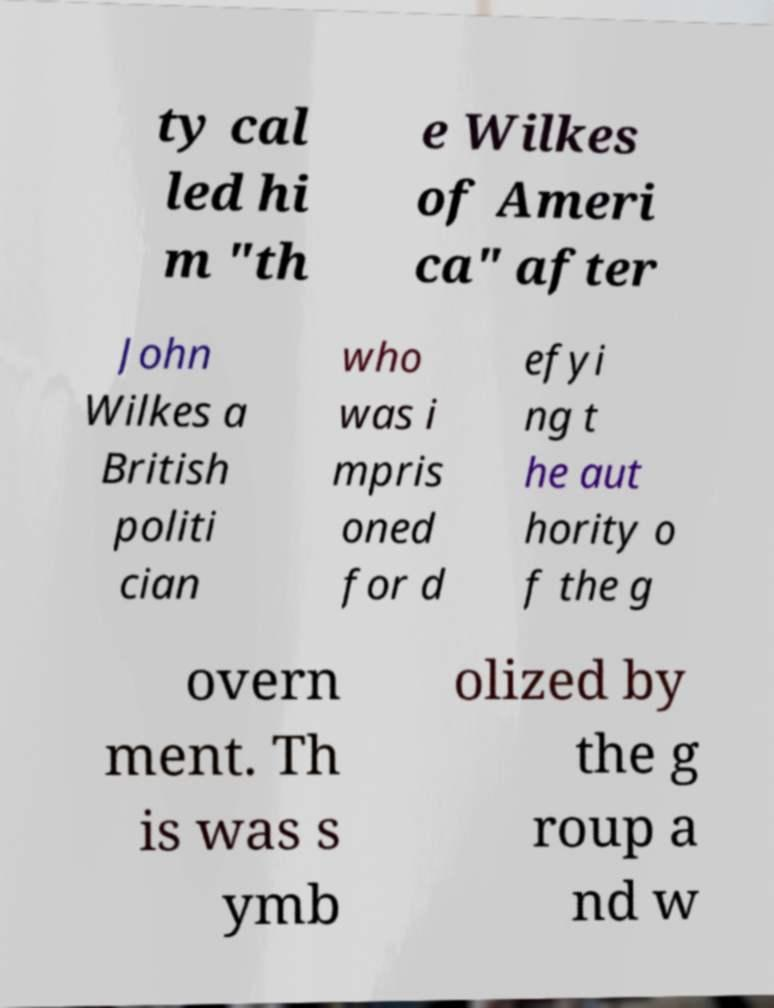Can you read and provide the text displayed in the image?This photo seems to have some interesting text. Can you extract and type it out for me? ty cal led hi m "th e Wilkes of Ameri ca" after John Wilkes a British politi cian who was i mpris oned for d efyi ng t he aut hority o f the g overn ment. Th is was s ymb olized by the g roup a nd w 